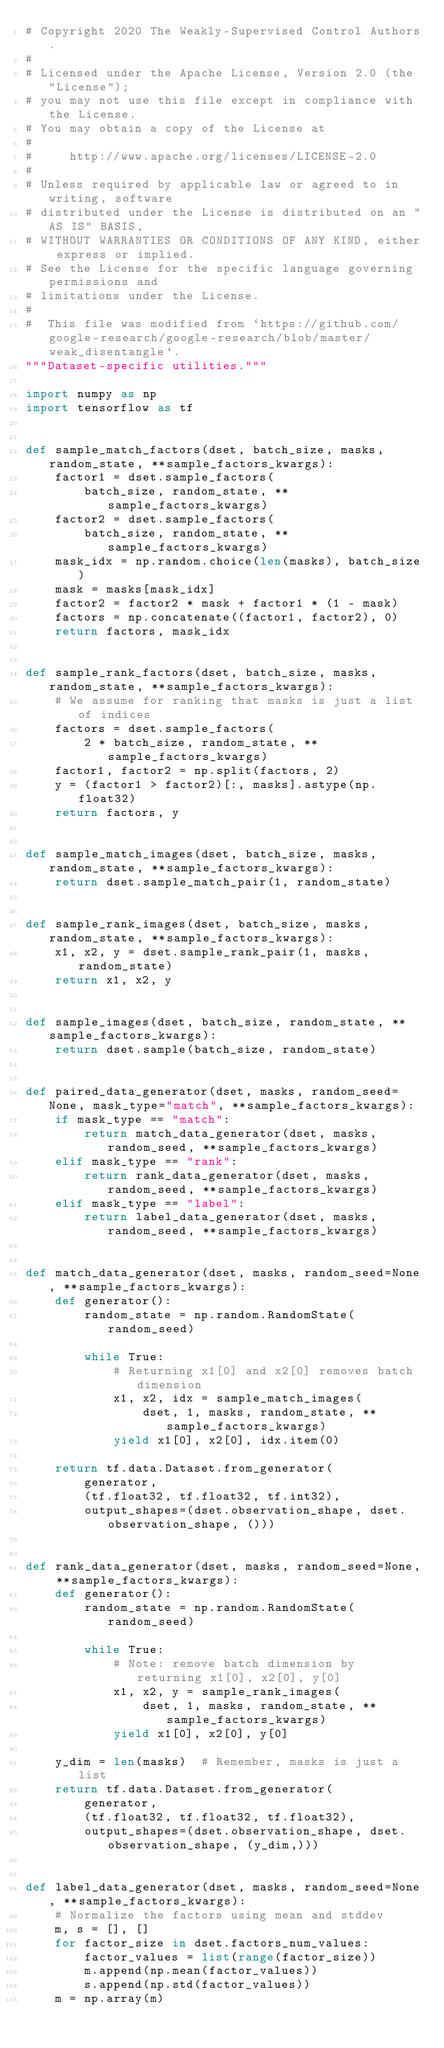Convert code to text. <code><loc_0><loc_0><loc_500><loc_500><_Python_># Copyright 2020 The Weakly-Supervised Control Authors.
#
# Licensed under the Apache License, Version 2.0 (the "License");
# you may not use this file except in compliance with the License.
# You may obtain a copy of the License at
#
#     http://www.apache.org/licenses/LICENSE-2.0
#
# Unless required by applicable law or agreed to in writing, software
# distributed under the License is distributed on an "AS IS" BASIS,
# WITHOUT WARRANTIES OR CONDITIONS OF ANY KIND, either express or implied.
# See the License for the specific language governing permissions and
# limitations under the License.
#
#  This file was modified from `https://github.com/google-research/google-research/blob/master/weak_disentangle`.
"""Dataset-specific utilities."""

import numpy as np
import tensorflow as tf


def sample_match_factors(dset, batch_size, masks, random_state, **sample_factors_kwargs):
    factor1 = dset.sample_factors(
        batch_size, random_state, **sample_factors_kwargs)
    factor2 = dset.sample_factors(
        batch_size, random_state, **sample_factors_kwargs)
    mask_idx = np.random.choice(len(masks), batch_size)
    mask = masks[mask_idx]
    factor2 = factor2 * mask + factor1 * (1 - mask)
    factors = np.concatenate((factor1, factor2), 0)
    return factors, mask_idx


def sample_rank_factors(dset, batch_size, masks, random_state, **sample_factors_kwargs):
    # We assume for ranking that masks is just a list of indices
    factors = dset.sample_factors(
        2 * batch_size, random_state, **sample_factors_kwargs)
    factor1, factor2 = np.split(factors, 2)
    y = (factor1 > factor2)[:, masks].astype(np.float32)
    return factors, y


def sample_match_images(dset, batch_size, masks, random_state, **sample_factors_kwargs):
    return dset.sample_match_pair(1, random_state)


def sample_rank_images(dset, batch_size, masks, random_state, **sample_factors_kwargs):
    x1, x2, y = dset.sample_rank_pair(1, masks, random_state)
    return x1, x2, y


def sample_images(dset, batch_size, random_state, **sample_factors_kwargs):
    return dset.sample(batch_size, random_state)


def paired_data_generator(dset, masks, random_seed=None, mask_type="match", **sample_factors_kwargs):
    if mask_type == "match":
        return match_data_generator(dset, masks, random_seed, **sample_factors_kwargs)
    elif mask_type == "rank":
        return rank_data_generator(dset, masks, random_seed, **sample_factors_kwargs)
    elif mask_type == "label":
        return label_data_generator(dset, masks, random_seed, **sample_factors_kwargs)


def match_data_generator(dset, masks, random_seed=None, **sample_factors_kwargs):
    def generator():
        random_state = np.random.RandomState(random_seed)

        while True:
            # Returning x1[0] and x2[0] removes batch dimension
            x1, x2, idx = sample_match_images(
                dset, 1, masks, random_state, **sample_factors_kwargs)
            yield x1[0], x2[0], idx.item(0)

    return tf.data.Dataset.from_generator(
        generator,
        (tf.float32, tf.float32, tf.int32),
        output_shapes=(dset.observation_shape, dset.observation_shape, ()))


def rank_data_generator(dset, masks, random_seed=None, **sample_factors_kwargs):
    def generator():
        random_state = np.random.RandomState(random_seed)

        while True:
            # Note: remove batch dimension by returning x1[0], x2[0], y[0]
            x1, x2, y = sample_rank_images(
                dset, 1, masks, random_state, **sample_factors_kwargs)
            yield x1[0], x2[0], y[0]

    y_dim = len(masks)  # Remember, masks is just a list
    return tf.data.Dataset.from_generator(
        generator,
        (tf.float32, tf.float32, tf.float32),
        output_shapes=(dset.observation_shape, dset.observation_shape, (y_dim,)))


def label_data_generator(dset, masks, random_seed=None, **sample_factors_kwargs):
    # Normalize the factors using mean and stddev
    m, s = [], []
    for factor_size in dset.factors_num_values:
        factor_values = list(range(factor_size))
        m.append(np.mean(factor_values))
        s.append(np.std(factor_values))
    m = np.array(m)</code> 